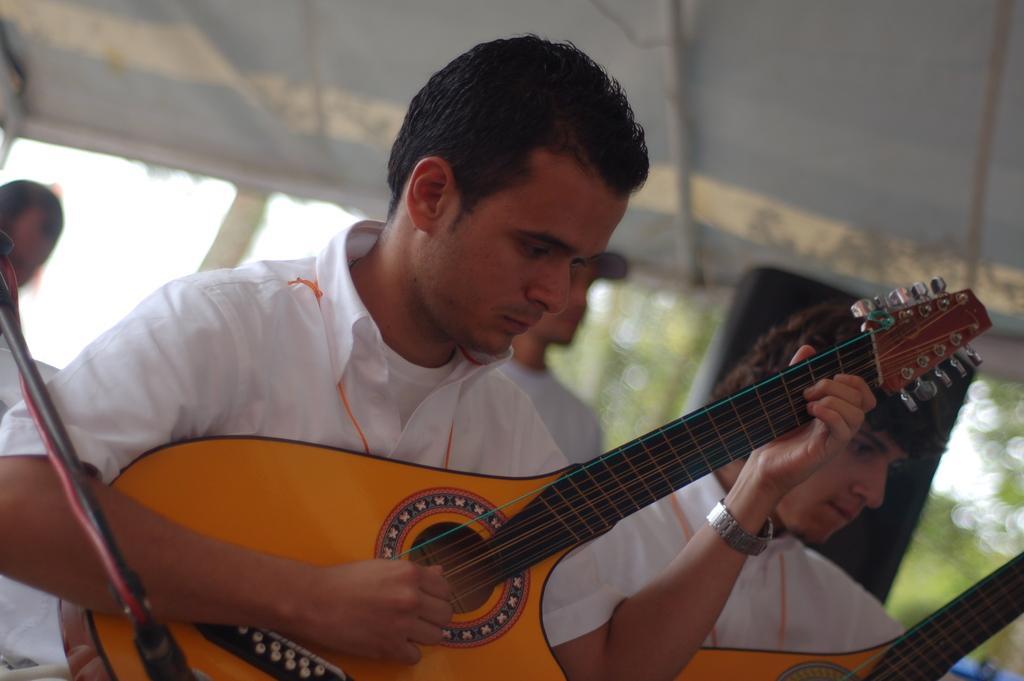Please provide a concise description of this image. In this picture, we see three men. The man on the left corner of this picture is holding guitar in his hands and playing it he is wearing white T-shirt and shirt. He is even wearing watch. The man the man on the right side is holding the guitar. The man behind is wearing cap. Behind them we can see sky and trees. We can even see the roof of the building. 